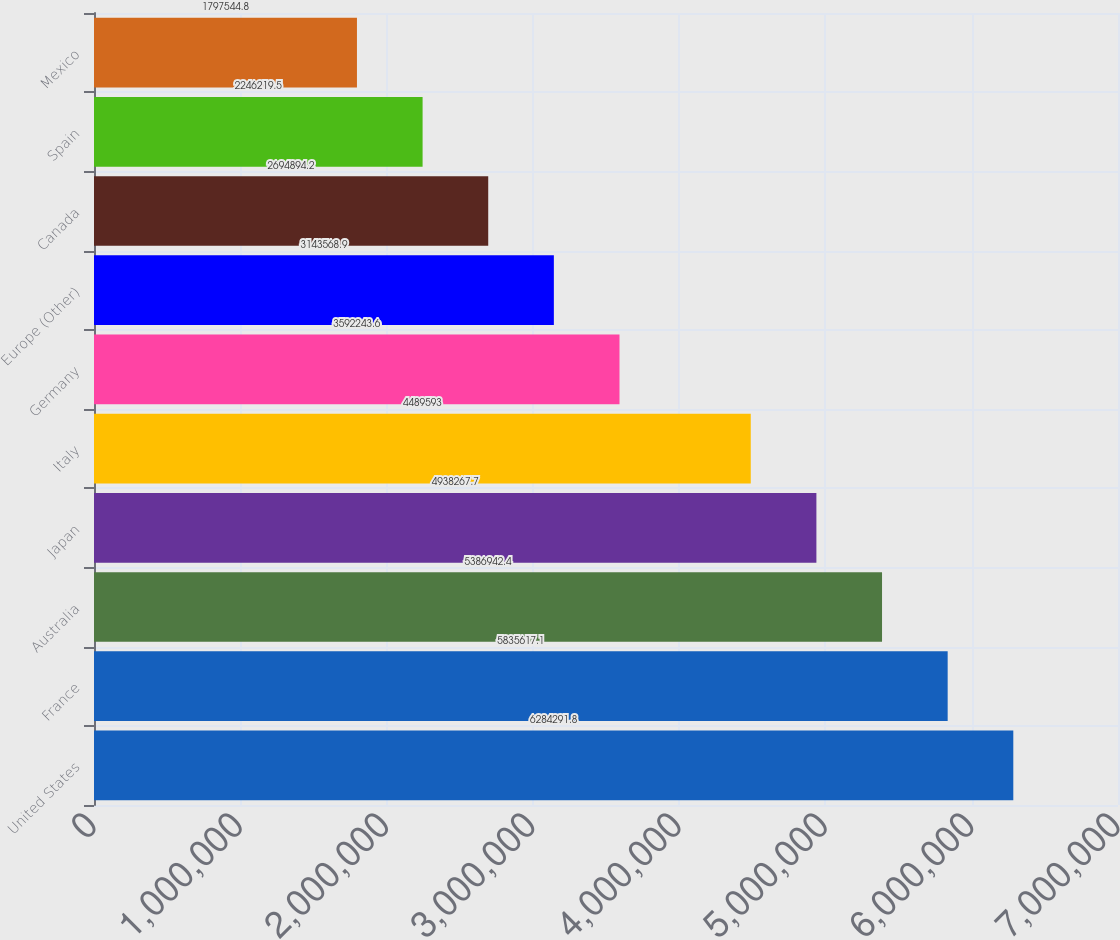<chart> <loc_0><loc_0><loc_500><loc_500><bar_chart><fcel>United States<fcel>France<fcel>Australia<fcel>Japan<fcel>Italy<fcel>Germany<fcel>Europe (Other)<fcel>Canada<fcel>Spain<fcel>Mexico<nl><fcel>6.28429e+06<fcel>5.83562e+06<fcel>5.38694e+06<fcel>4.93827e+06<fcel>4.48959e+06<fcel>3.59224e+06<fcel>3.14357e+06<fcel>2.69489e+06<fcel>2.24622e+06<fcel>1.79754e+06<nl></chart> 